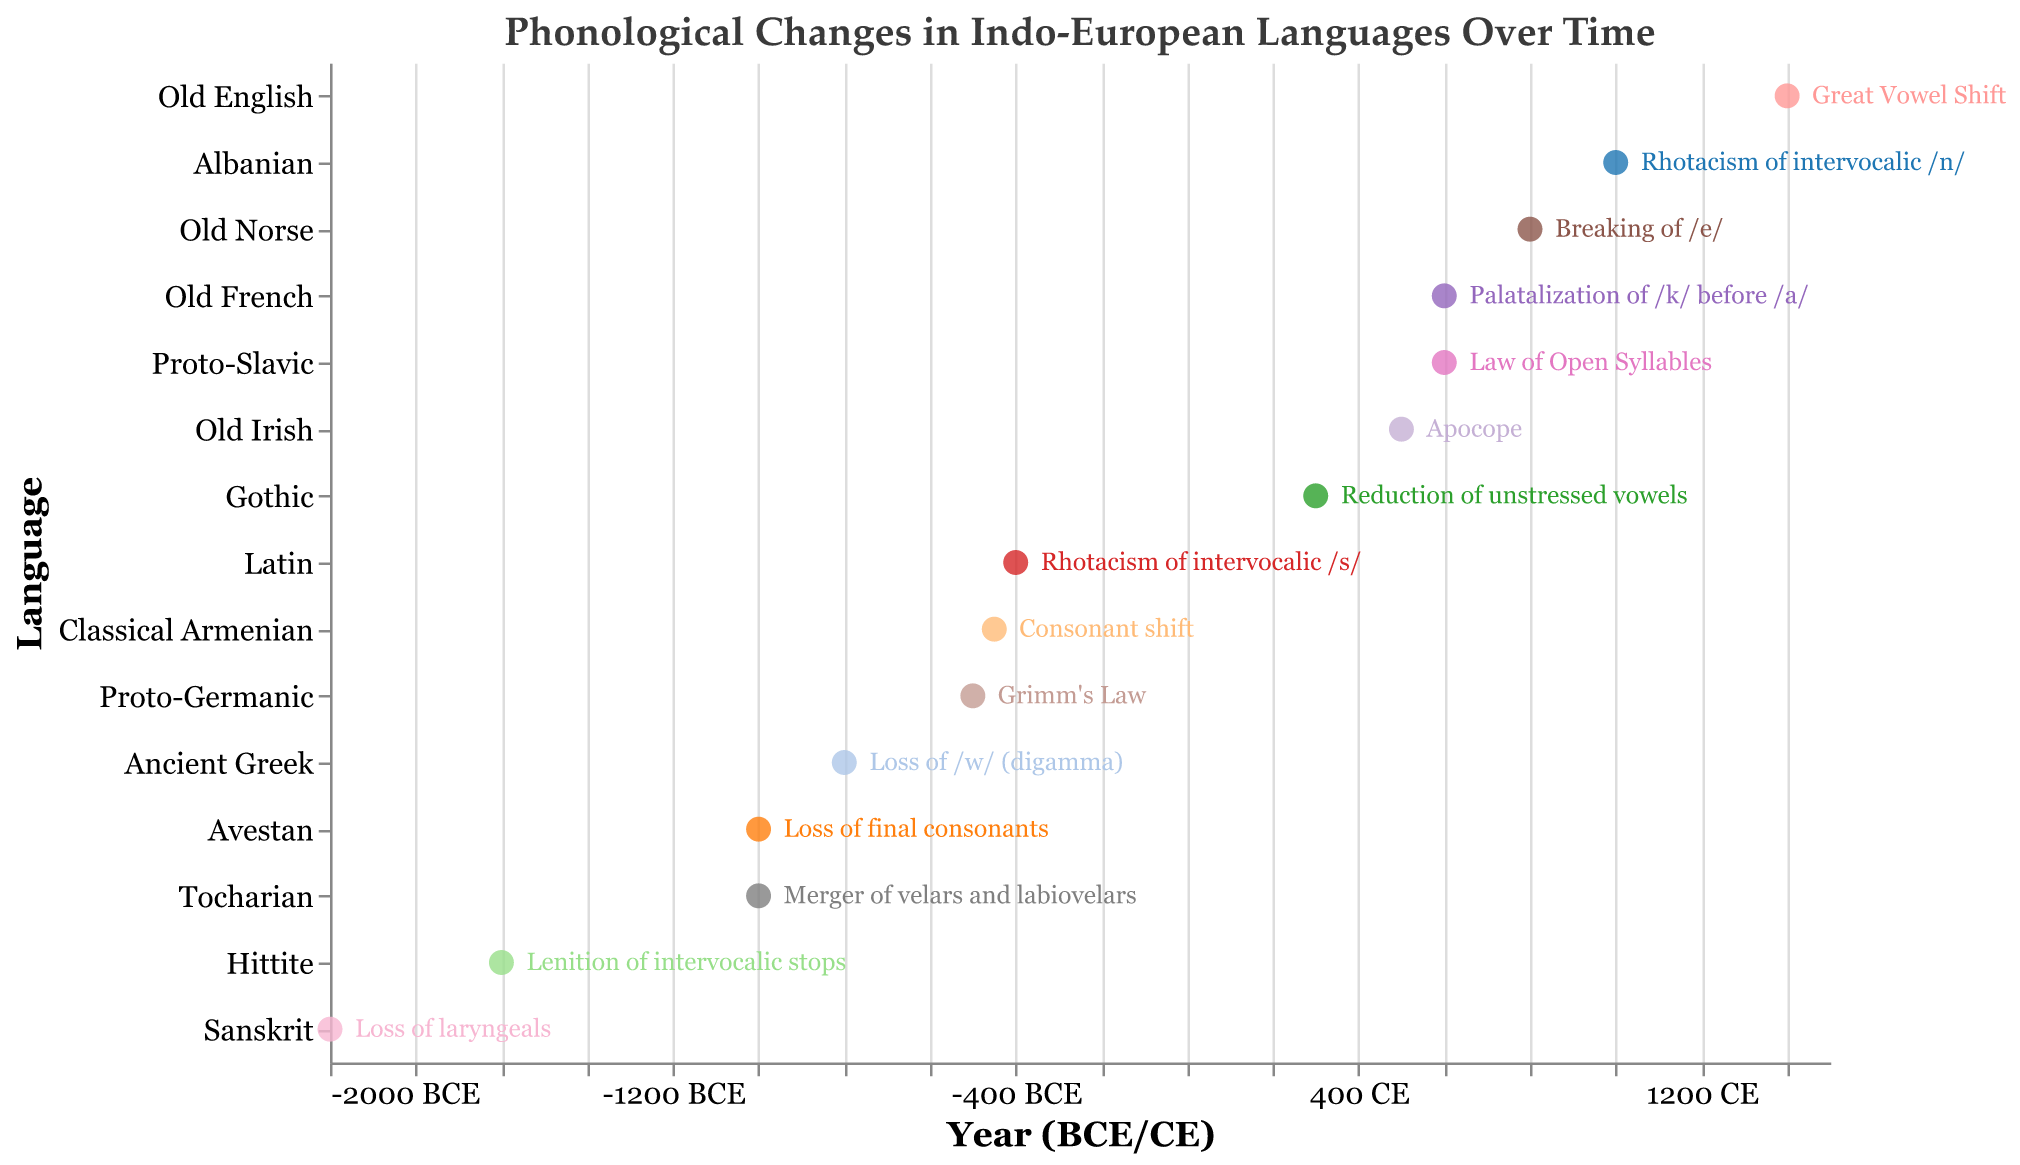How many phonological changes are depicted in the plot? The plot shows one phonological change for each of the 15 languages, so the total number of changes is 15.
Answer: 15 Which language experienced the earliest phonological change? By identifying the language positioned furthest to the left on the x-axis, we see that Sanskrit with "Loss of laryngeals" in 2000 BCE experienced the earliest change.
Answer: Sanskrit Compare the phonological changes between Ancient Greek and Old Norse in terms of years. Which occurred earlier? Ancient Greek's "Loss of /w/ (digamma)" occurred in 800 BCE, while Old Norse's "Breaking of /e/" occurred in 800 CE. Since BCE years are counted as negative and CE years as positive, 800 BCE is earlier than 800 CE.
Answer: Ancient Greek Which language listed on the plot has the most recent phonological change? The most recent change would be positioned furthest to the right on the x-axis in CE. Old English's "Great Vowel Shift" in 1400 CE is the most recent.
Answer: Old English How many languages experienced phonological changes before 500 BCE? By examining the languages with years shown as BCE and counting those prior to 500 BCE, we find that there are 5: Sanskrit, Avestan, Tocharian, Hittite, and Ancient Greek.
Answer: 5 What is the average year for the phonological changes in BCE? Calculate the average of the BCE years: (-2000 + -800 + -1600 + -500 + -450 + -1000 + -1000)/7 = -935 BCE
Answer: -935 BCE Of the languages that underwent changes in the CE period, which one is chronologically first? Consider languages with CE years. Gothic experienced "Reduction of unstressed vowels" in 300 CE, which is the earliest among CE years.
Answer: Gothic Is there any language that experienced a phonological change exactly in the mid-1st century CE? Mid-1st century CE refers to around 50 CE. The plot does not show any language with a phonological change at this time.
Answer: No Which language had a phonological change at around the same time as Proto-Slavic? Proto-Slavic's "Law of Open Syllables" happened in 600 CE. Old French experienced "Palatalization of /k/ before /a/" also in 600 CE. Thus, they are around the same time.
Answer: Old French What is the range of years (earliest to latest) for the phonological changes depicted in the plot? The earliest year is 2000 BCE (Sanskrit) and the latest is 1400 CE (Old English). To find the range, calculate the difference: 2000 BCE = -2000, thus the range from -2000 BCE to 1400 CE is 3400 years.
Answer: 3400 years 